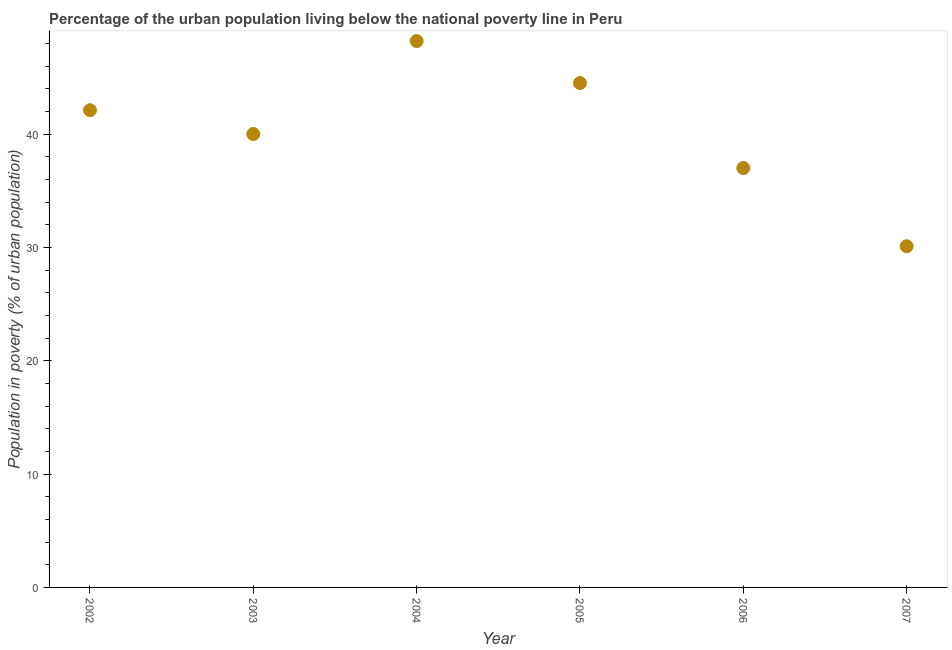Across all years, what is the maximum percentage of urban population living below poverty line?
Provide a short and direct response. 48.2. Across all years, what is the minimum percentage of urban population living below poverty line?
Make the answer very short. 30.1. In which year was the percentage of urban population living below poverty line maximum?
Your answer should be compact. 2004. What is the sum of the percentage of urban population living below poverty line?
Offer a terse response. 241.9. What is the average percentage of urban population living below poverty line per year?
Ensure brevity in your answer.  40.32. What is the median percentage of urban population living below poverty line?
Keep it short and to the point. 41.05. What is the ratio of the percentage of urban population living below poverty line in 2005 to that in 2006?
Provide a succinct answer. 1.2. What is the difference between the highest and the second highest percentage of urban population living below poverty line?
Offer a terse response. 3.7. In how many years, is the percentage of urban population living below poverty line greater than the average percentage of urban population living below poverty line taken over all years?
Provide a short and direct response. 3. Does the percentage of urban population living below poverty line monotonically increase over the years?
Offer a terse response. No. Does the graph contain any zero values?
Provide a succinct answer. No. Does the graph contain grids?
Ensure brevity in your answer.  No. What is the title of the graph?
Provide a short and direct response. Percentage of the urban population living below the national poverty line in Peru. What is the label or title of the Y-axis?
Provide a short and direct response. Population in poverty (% of urban population). What is the Population in poverty (% of urban population) in 2002?
Offer a terse response. 42.1. What is the Population in poverty (% of urban population) in 2003?
Offer a terse response. 40. What is the Population in poverty (% of urban population) in 2004?
Provide a succinct answer. 48.2. What is the Population in poverty (% of urban population) in 2005?
Provide a short and direct response. 44.5. What is the Population in poverty (% of urban population) in 2006?
Offer a very short reply. 37. What is the Population in poverty (% of urban population) in 2007?
Make the answer very short. 30.1. What is the difference between the Population in poverty (% of urban population) in 2002 and 2005?
Your answer should be very brief. -2.4. What is the difference between the Population in poverty (% of urban population) in 2002 and 2006?
Ensure brevity in your answer.  5.1. What is the difference between the Population in poverty (% of urban population) in 2003 and 2006?
Offer a terse response. 3. What is the difference between the Population in poverty (% of urban population) in 2003 and 2007?
Offer a very short reply. 9.9. What is the difference between the Population in poverty (% of urban population) in 2004 and 2005?
Make the answer very short. 3.7. What is the difference between the Population in poverty (% of urban population) in 2004 and 2007?
Offer a very short reply. 18.1. What is the difference between the Population in poverty (% of urban population) in 2005 and 2006?
Your response must be concise. 7.5. What is the ratio of the Population in poverty (% of urban population) in 2002 to that in 2003?
Your answer should be very brief. 1.05. What is the ratio of the Population in poverty (% of urban population) in 2002 to that in 2004?
Your response must be concise. 0.87. What is the ratio of the Population in poverty (% of urban population) in 2002 to that in 2005?
Make the answer very short. 0.95. What is the ratio of the Population in poverty (% of urban population) in 2002 to that in 2006?
Offer a terse response. 1.14. What is the ratio of the Population in poverty (% of urban population) in 2002 to that in 2007?
Provide a succinct answer. 1.4. What is the ratio of the Population in poverty (% of urban population) in 2003 to that in 2004?
Your answer should be very brief. 0.83. What is the ratio of the Population in poverty (% of urban population) in 2003 to that in 2005?
Your response must be concise. 0.9. What is the ratio of the Population in poverty (% of urban population) in 2003 to that in 2006?
Offer a terse response. 1.08. What is the ratio of the Population in poverty (% of urban population) in 2003 to that in 2007?
Offer a terse response. 1.33. What is the ratio of the Population in poverty (% of urban population) in 2004 to that in 2005?
Your response must be concise. 1.08. What is the ratio of the Population in poverty (% of urban population) in 2004 to that in 2006?
Give a very brief answer. 1.3. What is the ratio of the Population in poverty (% of urban population) in 2004 to that in 2007?
Your response must be concise. 1.6. What is the ratio of the Population in poverty (% of urban population) in 2005 to that in 2006?
Offer a terse response. 1.2. What is the ratio of the Population in poverty (% of urban population) in 2005 to that in 2007?
Ensure brevity in your answer.  1.48. What is the ratio of the Population in poverty (% of urban population) in 2006 to that in 2007?
Provide a succinct answer. 1.23. 